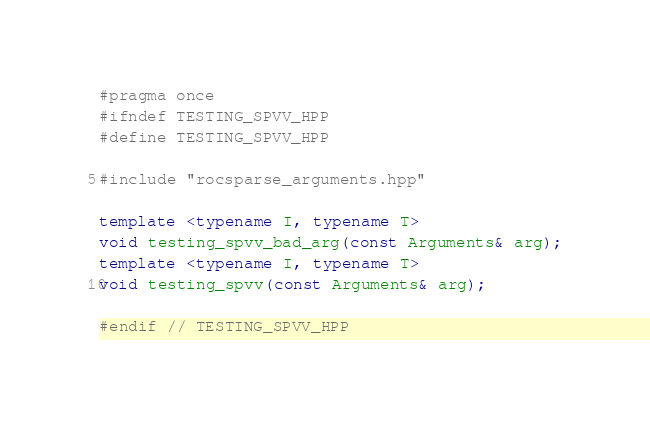<code> <loc_0><loc_0><loc_500><loc_500><_C++_>
#pragma once
#ifndef TESTING_SPVV_HPP
#define TESTING_SPVV_HPP

#include "rocsparse_arguments.hpp"

template <typename I, typename T>
void testing_spvv_bad_arg(const Arguments& arg);
template <typename I, typename T>
void testing_spvv(const Arguments& arg);

#endif // TESTING_SPVV_HPP
</code> 